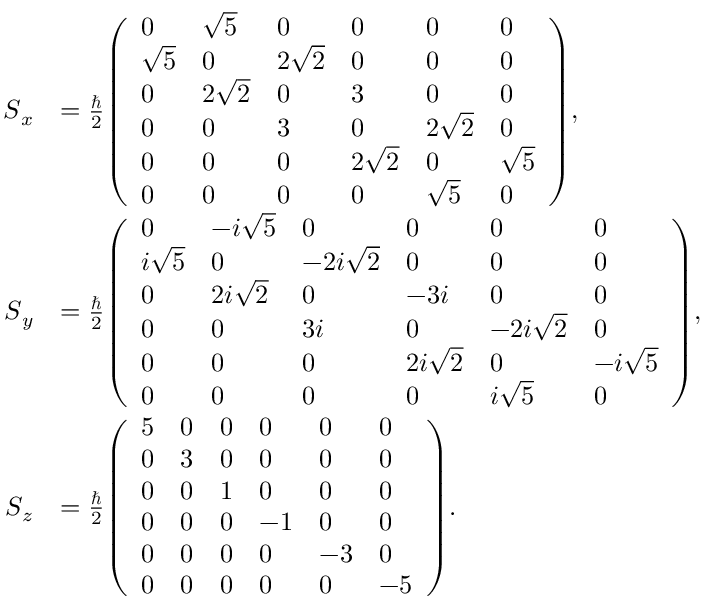<formula> <loc_0><loc_0><loc_500><loc_500>{ \begin{array} { r l } { { S } _ { x } } & { = { \frac { } { 2 } } { \left ( \begin{array} { l l l l l l } { 0 } & { { \sqrt { 5 } } } & { 0 } & { 0 } & { 0 } & { 0 } \\ { { \sqrt { 5 } } } & { 0 } & { 2 { \sqrt { 2 } } } & { 0 } & { 0 } & { 0 } \\ { 0 } & { 2 { \sqrt { 2 } } } & { 0 } & { 3 } & { 0 } & { 0 } \\ { 0 } & { 0 } & { 3 } & { 0 } & { 2 { \sqrt { 2 } } } & { 0 } \\ { 0 } & { 0 } & { 0 } & { 2 { \sqrt { 2 } } } & { 0 } & { { \sqrt { 5 } } } \\ { 0 } & { 0 } & { 0 } & { 0 } & { { \sqrt { 5 } } } & { 0 } \end{array} \right ) } , } \\ { { S } _ { y } } & { = { \frac { } { 2 } } { \left ( \begin{array} { l l l l l l } { 0 } & { - i { \sqrt { 5 } } } & { 0 } & { 0 } & { 0 } & { 0 } \\ { i { \sqrt { 5 } } } & { 0 } & { - 2 i { \sqrt { 2 } } } & { 0 } & { 0 } & { 0 } \\ { 0 } & { 2 i { \sqrt { 2 } } } & { 0 } & { - 3 i } & { 0 } & { 0 } \\ { 0 } & { 0 } & { 3 i } & { 0 } & { - 2 i { \sqrt { 2 } } } & { 0 } \\ { 0 } & { 0 } & { 0 } & { 2 i { \sqrt { 2 } } } & { 0 } & { - i { \sqrt { 5 } } } \\ { 0 } & { 0 } & { 0 } & { 0 } & { i { \sqrt { 5 } } } & { 0 } \end{array} \right ) } , } \\ { { S } _ { z } } & { = { \frac { } { 2 } } { \left ( \begin{array} { l l l l l l } { 5 } & { 0 } & { 0 } & { 0 } & { 0 } & { 0 } \\ { 0 } & { 3 } & { 0 } & { 0 } & { 0 } & { 0 } \\ { 0 } & { 0 } & { 1 } & { 0 } & { 0 } & { 0 } \\ { 0 } & { 0 } & { 0 } & { - 1 } & { 0 } & { 0 } \\ { 0 } & { 0 } & { 0 } & { 0 } & { - 3 } & { 0 } \\ { 0 } & { 0 } & { 0 } & { 0 } & { 0 } & { - 5 } \end{array} \right ) } . } \end{array} }</formula> 